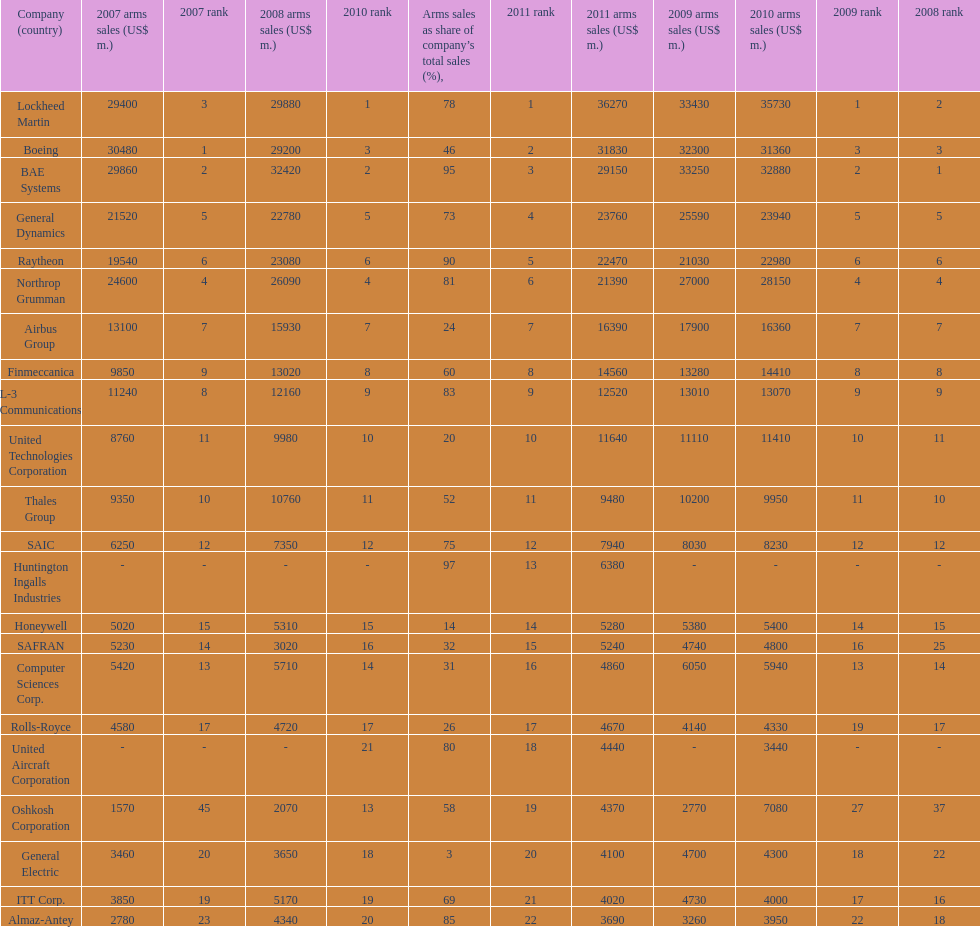How many different countries are listed? 6. 